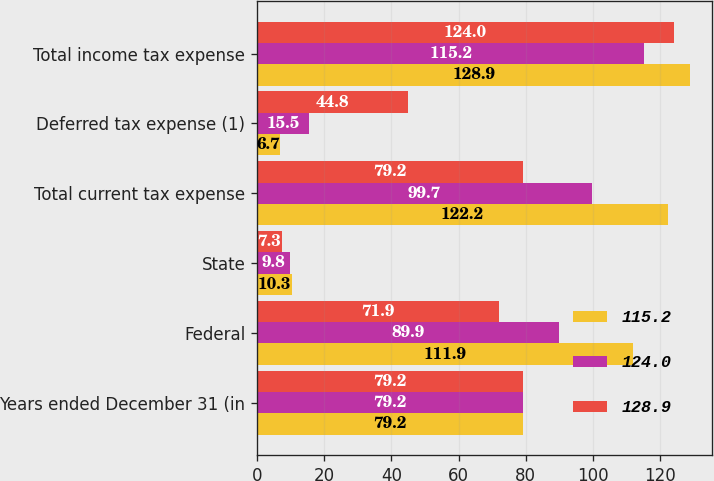Convert chart to OTSL. <chart><loc_0><loc_0><loc_500><loc_500><stacked_bar_chart><ecel><fcel>Years ended December 31 (in<fcel>Federal<fcel>State<fcel>Total current tax expense<fcel>Deferred tax expense (1)<fcel>Total income tax expense<nl><fcel>115.2<fcel>79.2<fcel>111.9<fcel>10.3<fcel>122.2<fcel>6.7<fcel>128.9<nl><fcel>124<fcel>79.2<fcel>89.9<fcel>9.8<fcel>99.7<fcel>15.5<fcel>115.2<nl><fcel>128.9<fcel>79.2<fcel>71.9<fcel>7.3<fcel>79.2<fcel>44.8<fcel>124<nl></chart> 